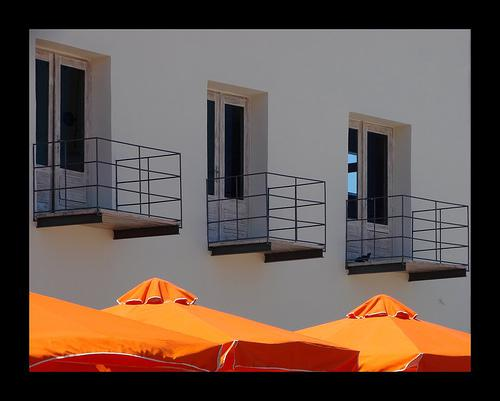Question: where are the umbrellas?
Choices:
A. In the sand.
B. Under balcony.
C. In the car.
D. Under the person's arm.
Answer with the letter. Answer: B Question: how many balconies are there?
Choices:
A. One.
B. Two.
C. Three.
D. Four.
Answer with the letter. Answer: C Question: who is on the balcony?
Choices:
A. No one.
B. A child.
C. A young couple.
D. A family.
Answer with the letter. Answer: A Question: what type of day is it?
Choices:
A. Sunny.
B. Cloudy.
C. Rainy.
D. Snowy.
Answer with the letter. Answer: A Question: what color are the umbrellas?
Choices:
A. Blue.
B. Black.
C. Orange.
D. Rainbow.
Answer with the letter. Answer: C 